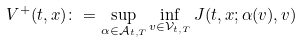Convert formula to latex. <formula><loc_0><loc_0><loc_500><loc_500>V ^ { + } ( t , x ) \colon = \sup _ { \alpha \in \mathcal { A } _ { t , T } } \inf _ { v \in \mathcal { V } _ { t , T } } J ( t , x ; \alpha ( v ) , v )</formula> 